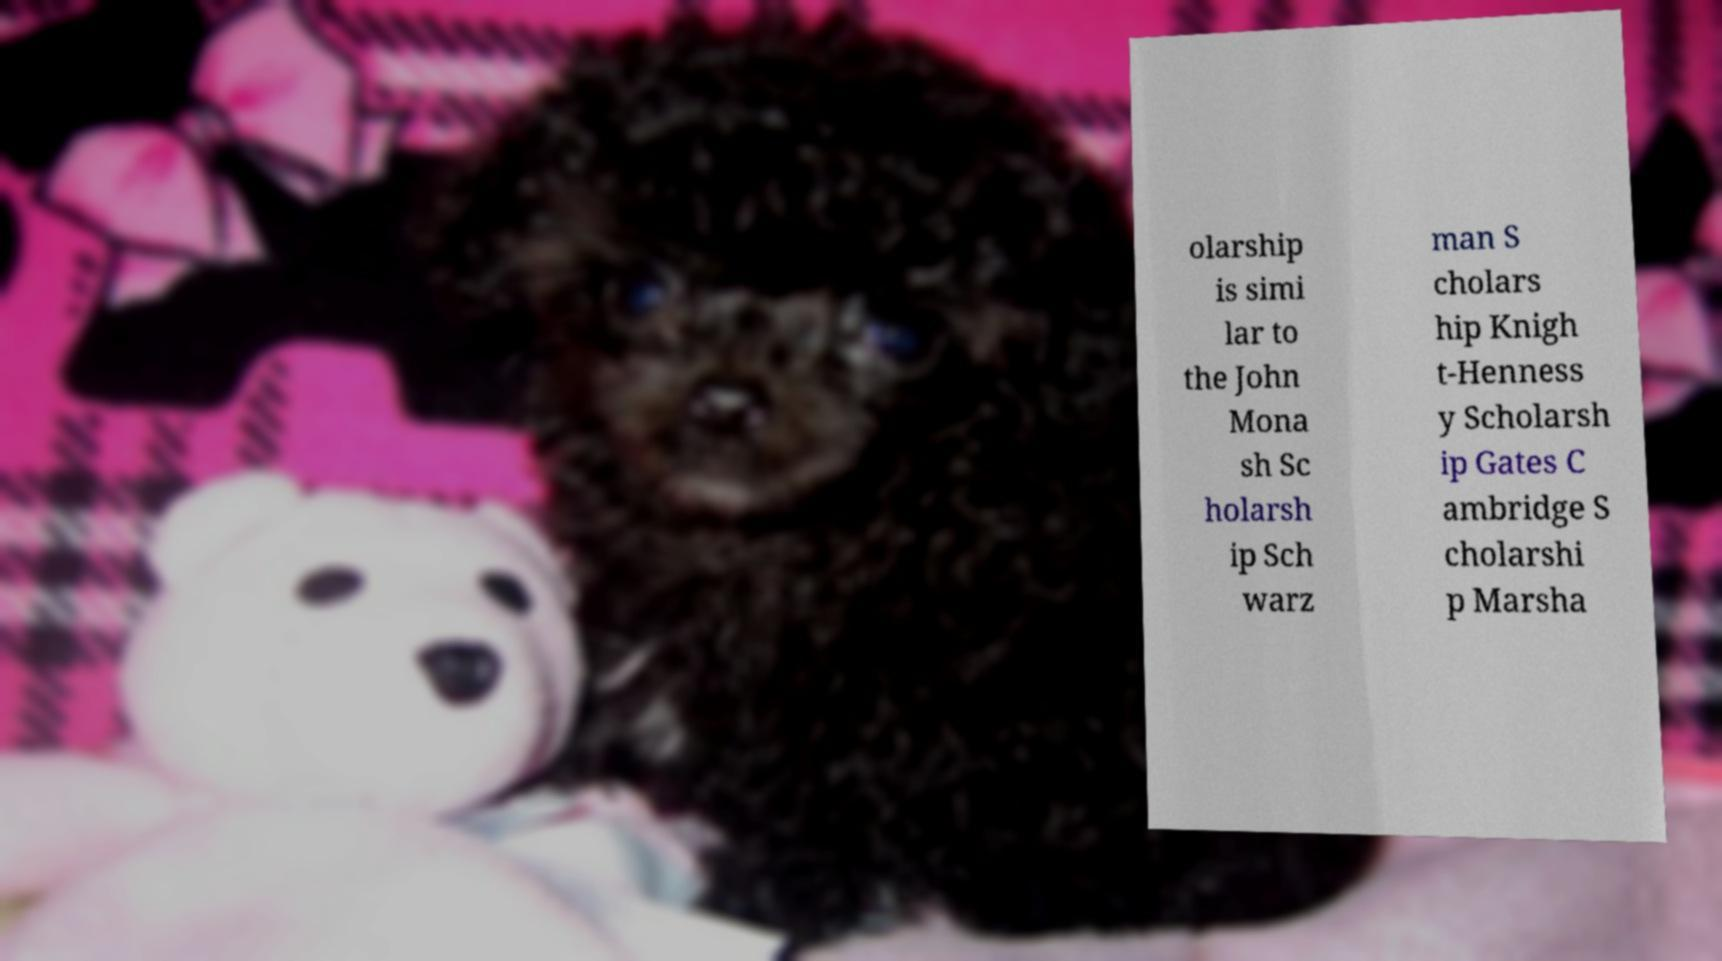There's text embedded in this image that I need extracted. Can you transcribe it verbatim? olarship is simi lar to the John Mona sh Sc holarsh ip Sch warz man S cholars hip Knigh t-Henness y Scholarsh ip Gates C ambridge S cholarshi p Marsha 